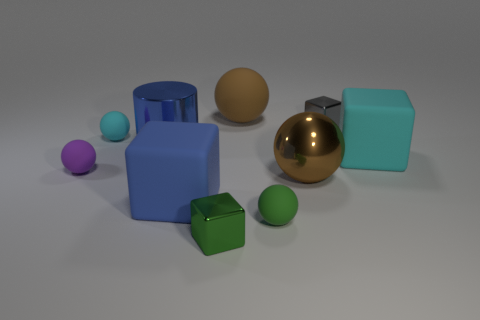What textures are visible on the objects in this setup, and which object stands out the most because of its texture? The objects in the image display a variety of textures: the purple and green small spheres have a matte finish, as does the large blue square object; the gold sphere has a reflective, glossy finish. The large gold sphere stands out the most due to its highly reflective, shiny texture that contrasts with the matte finishes of the other objects. 